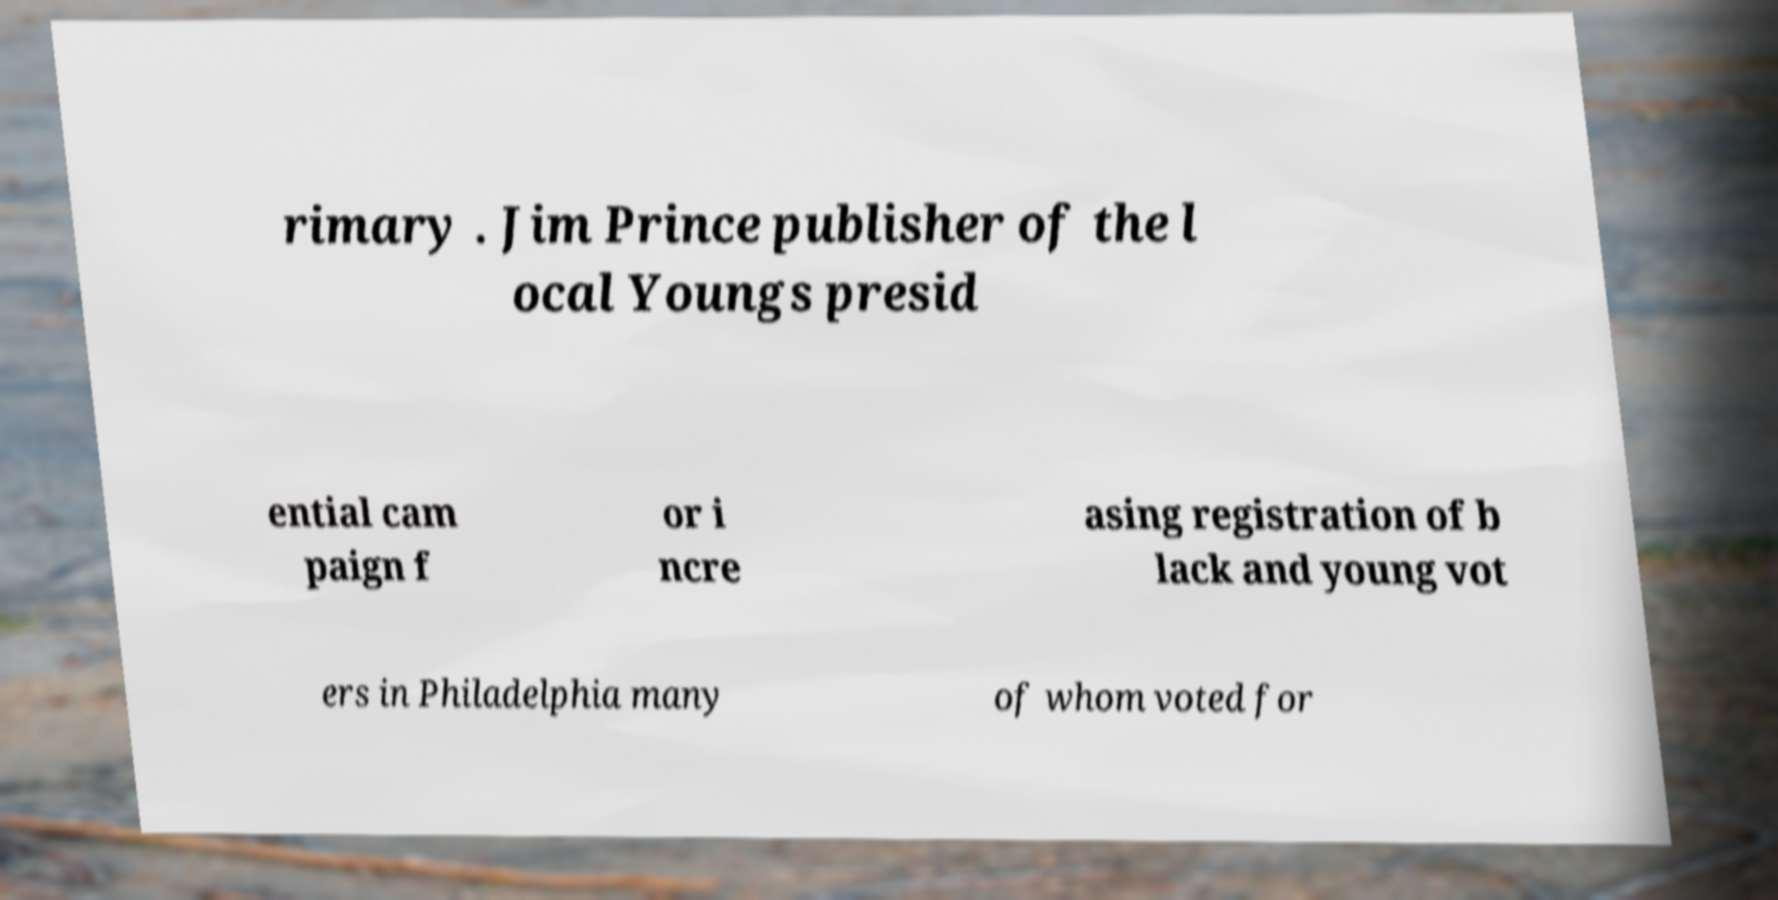For documentation purposes, I need the text within this image transcribed. Could you provide that? rimary . Jim Prince publisher of the l ocal Youngs presid ential cam paign f or i ncre asing registration of b lack and young vot ers in Philadelphia many of whom voted for 